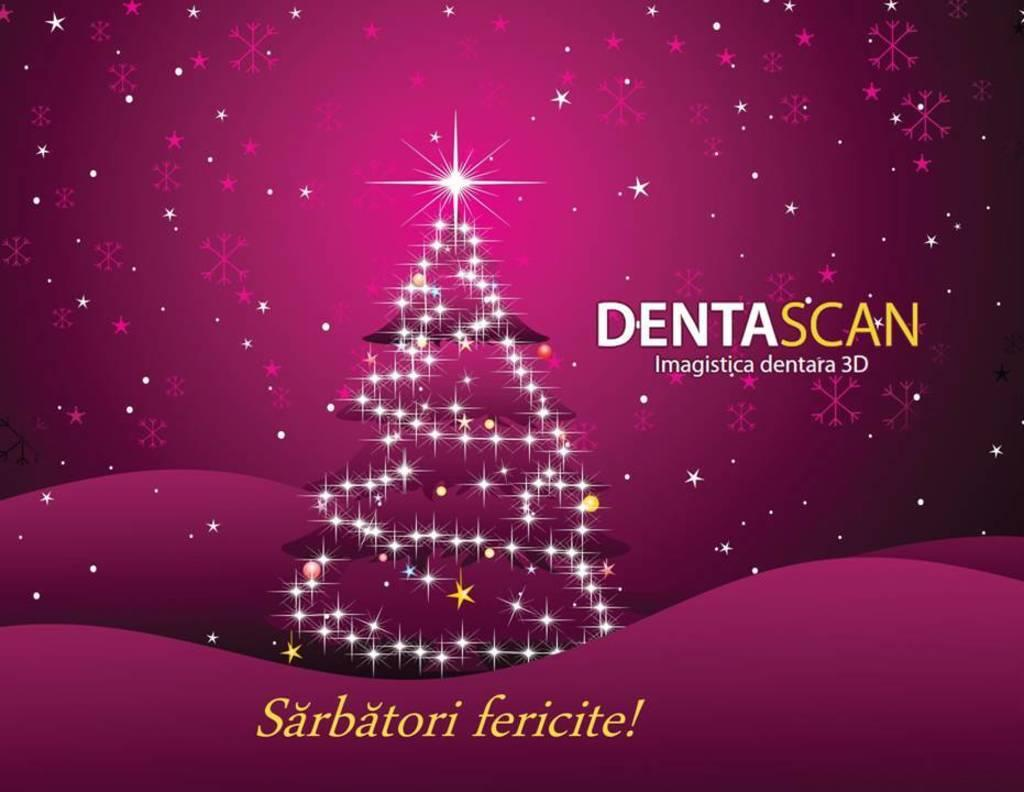What type of image is depicted in the poster? The image is a poster. What is the main subject of the poster? There is a Christmas tree on the poster. What additional elements can be seen on the poster? There are lights on the poster. Is there any text present on the poster? Yes, there is some text on the poster. What type of root can be seen growing from the bottom of the Christmas tree in the poster? There is no root visible in the poster, as it features a Christmas tree with lights and text. What type of cannon is present near the Christmas tree in the poster? There is no cannon present in the poster; it only features a Christmas tree, lights, and text. 